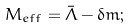Convert formula to latex. <formula><loc_0><loc_0><loc_500><loc_500>M _ { e f f } = \bar { \Lambda } - \delta m ;</formula> 